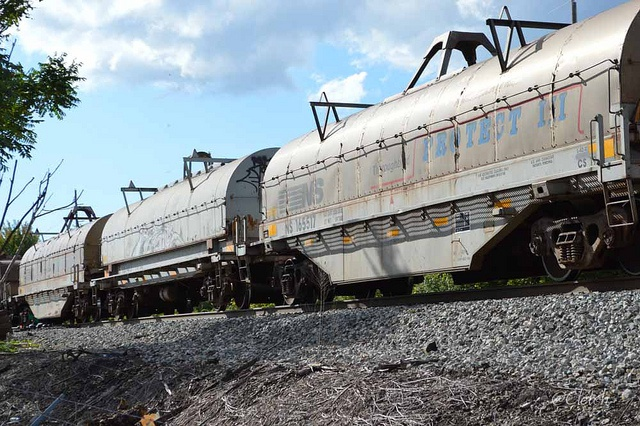Describe the objects in this image and their specific colors. I can see a train in darkgray, lightgray, black, and gray tones in this image. 